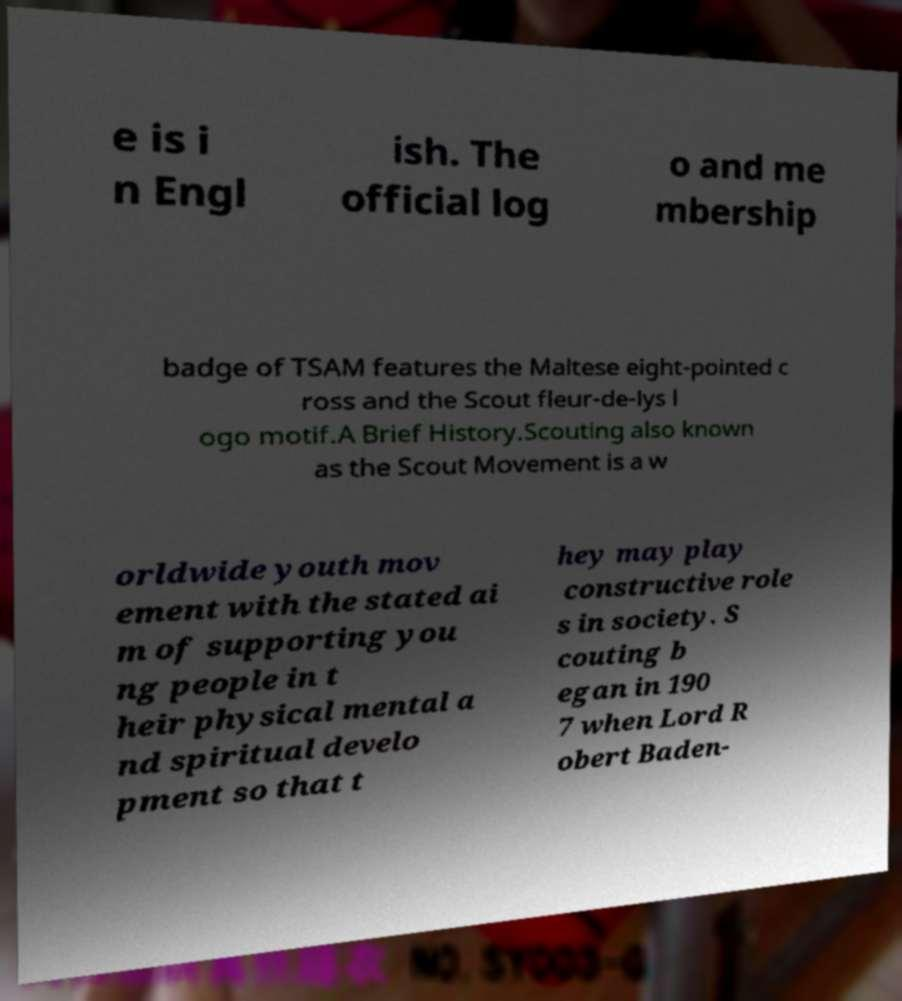Please identify and transcribe the text found in this image. e is i n Engl ish. The official log o and me mbership badge of TSAM features the Maltese eight-pointed c ross and the Scout fleur-de-lys l ogo motif.A Brief History.Scouting also known as the Scout Movement is a w orldwide youth mov ement with the stated ai m of supporting you ng people in t heir physical mental a nd spiritual develo pment so that t hey may play constructive role s in society. S couting b egan in 190 7 when Lord R obert Baden- 